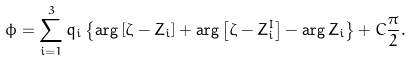Convert formula to latex. <formula><loc_0><loc_0><loc_500><loc_500>\phi = \sum _ { i = 1 } ^ { 3 } q _ { i } \left \{ \arg \left [ \zeta - Z _ { i } \right ] + \arg \left [ \zeta - Z _ { i } ^ { I } \right ] - \arg Z _ { i } \right \} + C \frac { \pi } { 2 } .</formula> 